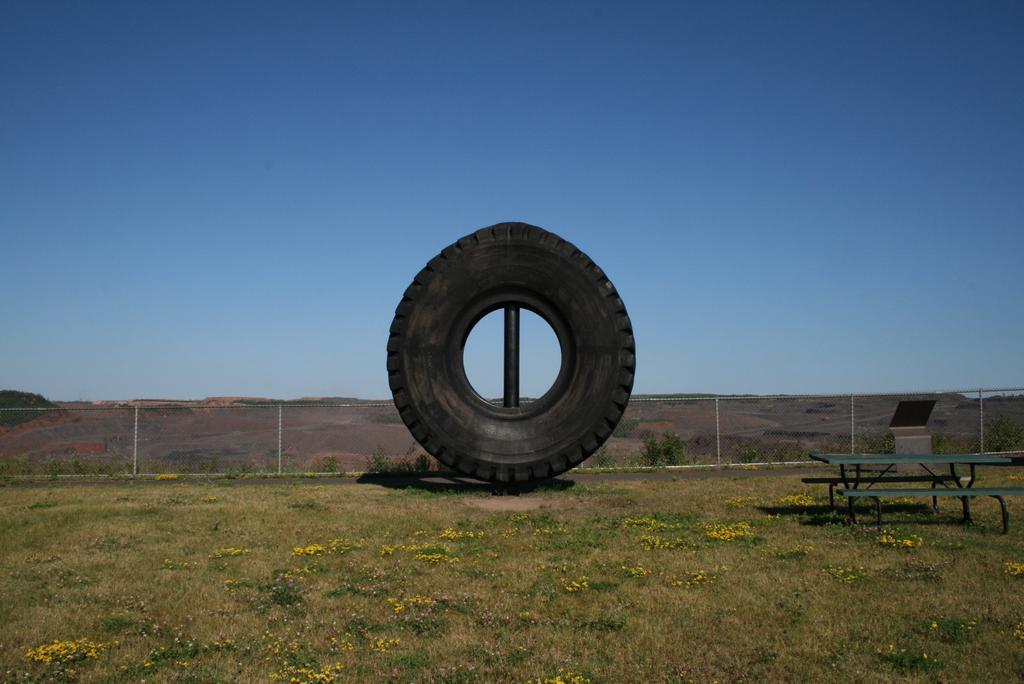Can you describe this image briefly? In this picture there is a tyre in the middle of ground. There is a bench to the right side. At the top there is sky. At the background there is a fencing. There are flower plants on the ground. 